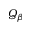Convert formula to latex. <formula><loc_0><loc_0><loc_500><loc_500>Q _ { \beta }</formula> 